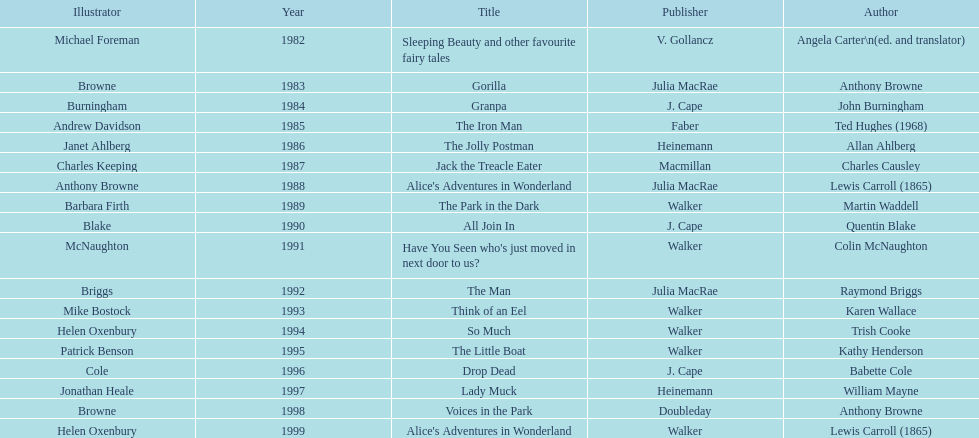Which book won the award a total of 2 times? Alice's Adventures in Wonderland. 